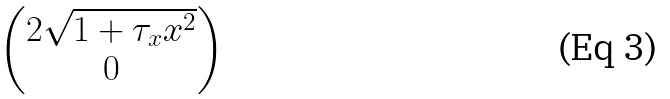Convert formula to latex. <formula><loc_0><loc_0><loc_500><loc_500>\begin{pmatrix} 2 \sqrt { 1 + \tau _ { x } x ^ { 2 } } \\ 0 \end{pmatrix}</formula> 